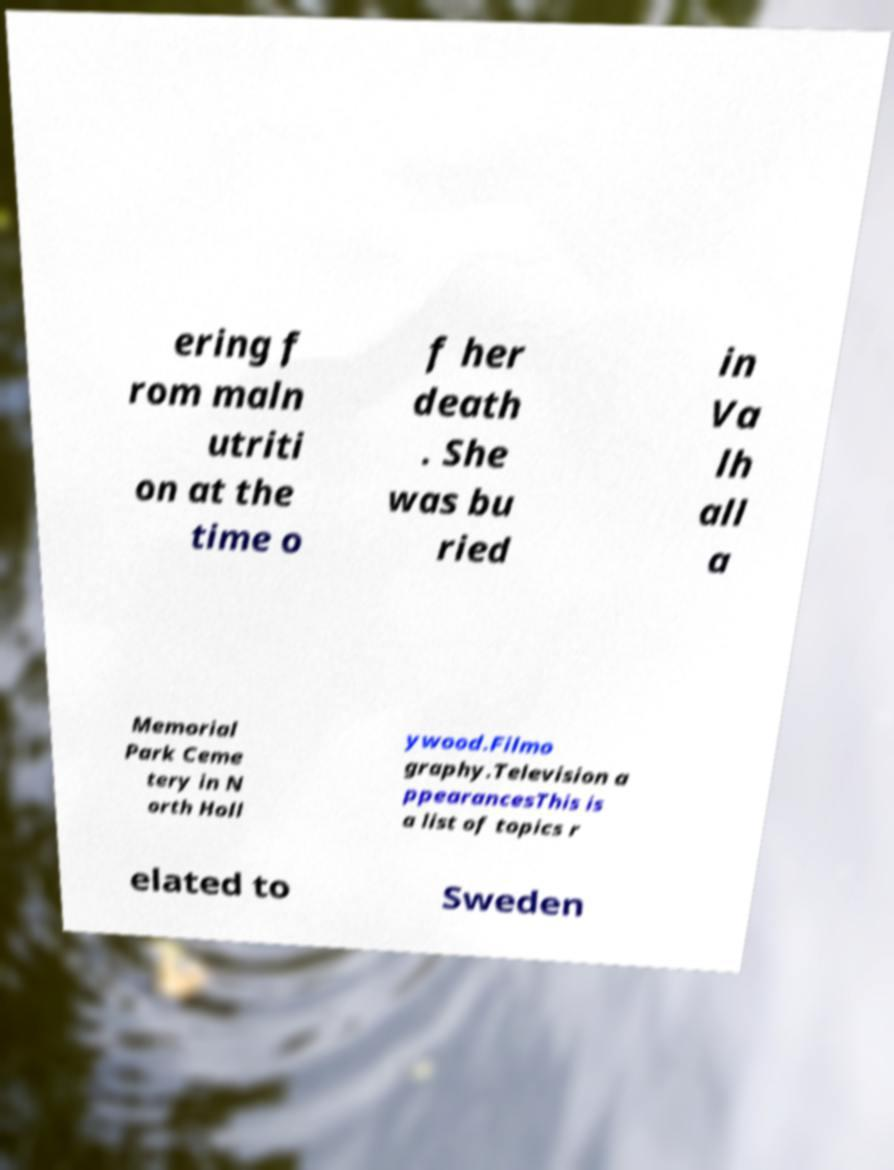Could you assist in decoding the text presented in this image and type it out clearly? ering f rom maln utriti on at the time o f her death . She was bu ried in Va lh all a Memorial Park Ceme tery in N orth Holl ywood.Filmo graphy.Television a ppearancesThis is a list of topics r elated to Sweden 